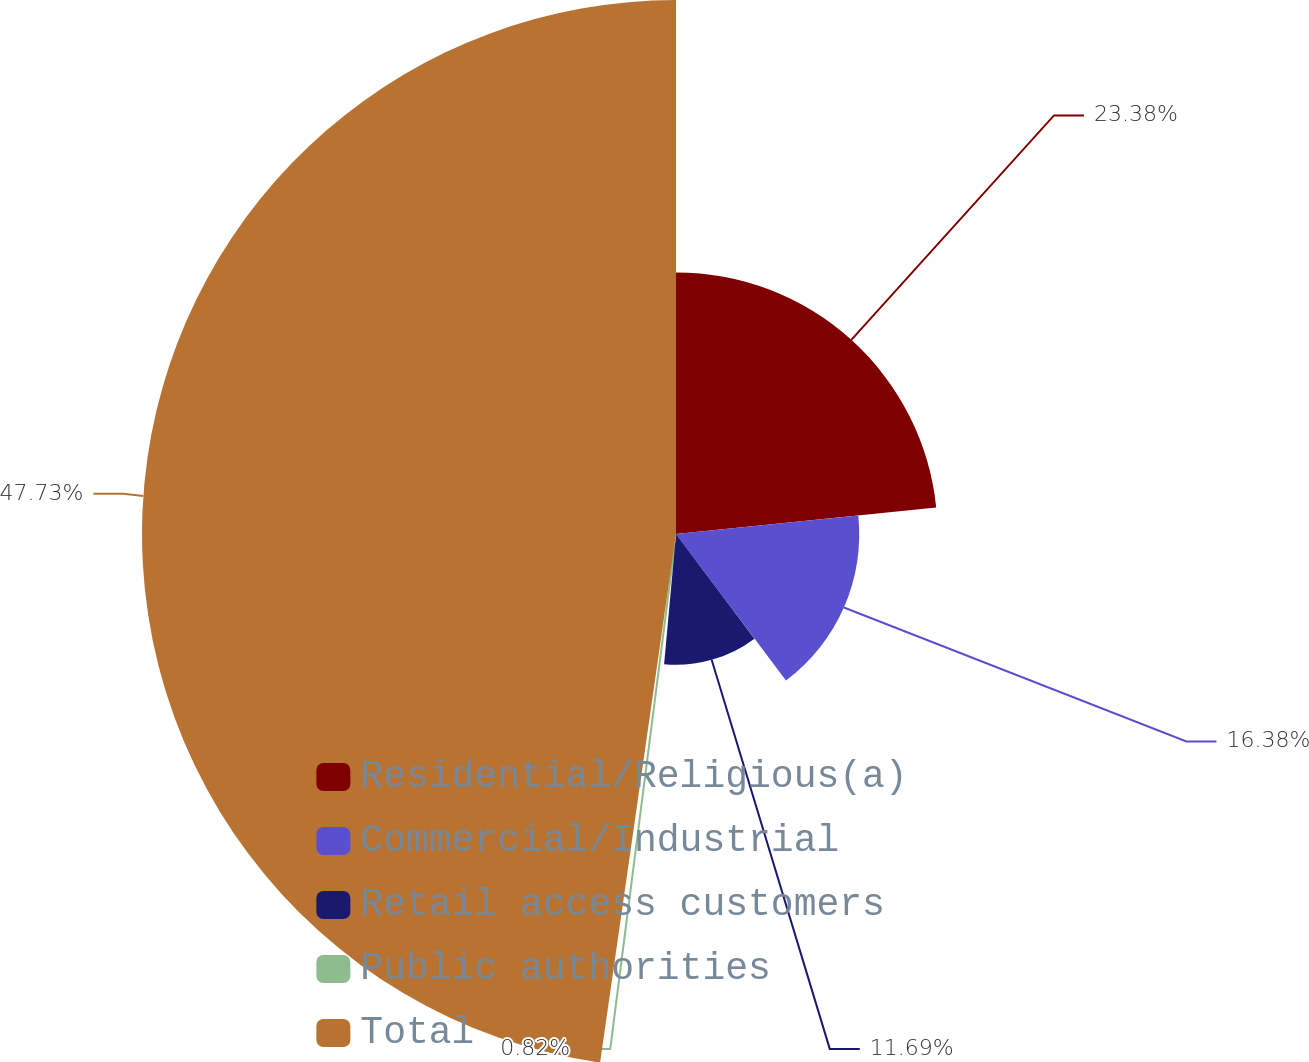Convert chart. <chart><loc_0><loc_0><loc_500><loc_500><pie_chart><fcel>Residential/Religious(a)<fcel>Commercial/Industrial<fcel>Retail access customers<fcel>Public authorities<fcel>Total<nl><fcel>23.38%<fcel>16.38%<fcel>11.69%<fcel>0.82%<fcel>47.73%<nl></chart> 